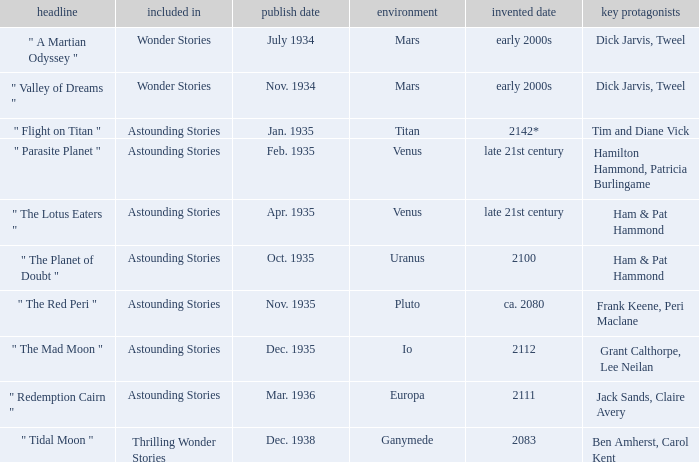Name what was published in july 1934 with a setting of mars Wonder Stories. 